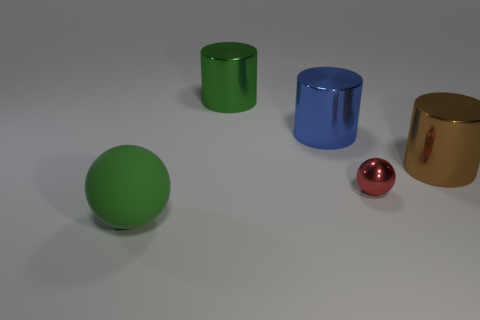How many other objects are the same material as the large brown cylinder?
Give a very brief answer. 3. Are there any tiny shiny things behind the metallic sphere?
Keep it short and to the point. No. There is a brown metal thing; does it have the same size as the sphere to the left of the large green cylinder?
Your answer should be very brief. Yes. There is a big object in front of the metallic object right of the small red sphere; what is its color?
Offer a terse response. Green. Do the rubber thing and the red metallic thing have the same size?
Keep it short and to the point. No. What is the color of the metallic object that is both right of the large blue metal cylinder and behind the small shiny object?
Your answer should be very brief. Brown. The metal sphere has what size?
Ensure brevity in your answer.  Small. There is a large object right of the small red metal ball; is its color the same as the matte ball?
Make the answer very short. No. Are there more red spheres to the right of the brown shiny cylinder than metallic spheres that are behind the green cylinder?
Ensure brevity in your answer.  No. Is the number of blue things greater than the number of large cyan rubber objects?
Offer a terse response. Yes. 